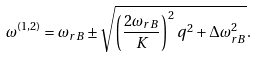Convert formula to latex. <formula><loc_0><loc_0><loc_500><loc_500>\omega ^ { ( 1 , 2 ) } = \omega _ { r { B } } \pm \sqrt { \left ( \frac { 2 \omega _ { r { B } } } { K } \right ) ^ { 2 } q ^ { 2 } + \Delta \omega _ { r { B } } ^ { 2 } } .</formula> 